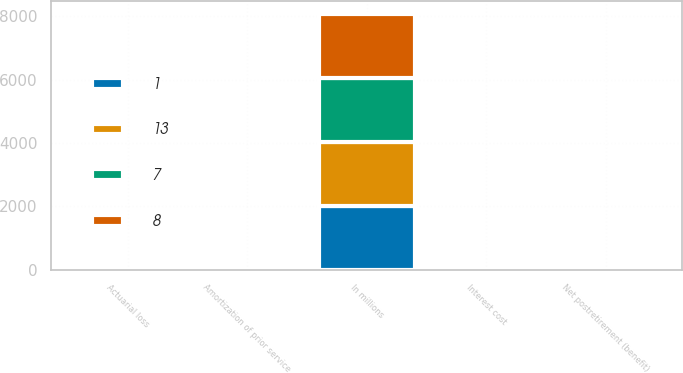<chart> <loc_0><loc_0><loc_500><loc_500><stacked_bar_chart><ecel><fcel>In millions<fcel>Interest cost<fcel>Actuarial loss<fcel>Amortization of prior service<fcel>Net postretirement (benefit)<nl><fcel>1<fcel>2016<fcel>11<fcel>5<fcel>4<fcel>13<nl><fcel>13<fcel>2016<fcel>3<fcel>2<fcel>4<fcel>1<nl><fcel>7<fcel>2015<fcel>11<fcel>6<fcel>10<fcel>8<nl><fcel>8<fcel>2015<fcel>5<fcel>1<fcel>2<fcel>5<nl></chart> 